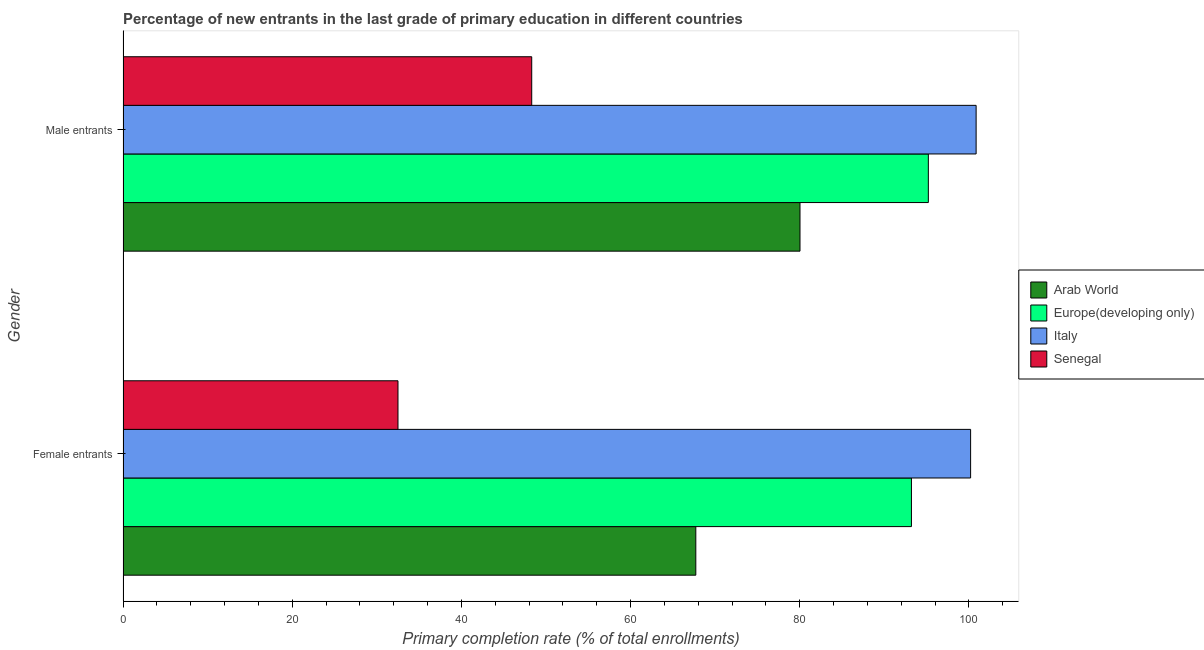How many groups of bars are there?
Offer a terse response. 2. Are the number of bars per tick equal to the number of legend labels?
Your answer should be compact. Yes. Are the number of bars on each tick of the Y-axis equal?
Your answer should be compact. Yes. What is the label of the 1st group of bars from the top?
Offer a very short reply. Male entrants. What is the primary completion rate of male entrants in Europe(developing only)?
Provide a short and direct response. 95.21. Across all countries, what is the maximum primary completion rate of female entrants?
Keep it short and to the point. 100.21. Across all countries, what is the minimum primary completion rate of female entrants?
Make the answer very short. 32.51. In which country was the primary completion rate of male entrants minimum?
Give a very brief answer. Senegal. What is the total primary completion rate of female entrants in the graph?
Offer a terse response. 293.65. What is the difference between the primary completion rate of female entrants in Senegal and that in Arab World?
Provide a short and direct response. -35.21. What is the difference between the primary completion rate of female entrants in Arab World and the primary completion rate of male entrants in Senegal?
Your answer should be compact. 19.4. What is the average primary completion rate of male entrants per country?
Provide a succinct answer. 81.11. What is the difference between the primary completion rate of female entrants and primary completion rate of male entrants in Senegal?
Offer a terse response. -15.81. What is the ratio of the primary completion rate of female entrants in Arab World to that in Italy?
Give a very brief answer. 0.68. What does the 1st bar from the top in Male entrants represents?
Offer a very short reply. Senegal. How many bars are there?
Make the answer very short. 8. How many countries are there in the graph?
Ensure brevity in your answer.  4. Where does the legend appear in the graph?
Offer a very short reply. Center right. What is the title of the graph?
Your answer should be very brief. Percentage of new entrants in the last grade of primary education in different countries. Does "Grenada" appear as one of the legend labels in the graph?
Your response must be concise. No. What is the label or title of the X-axis?
Make the answer very short. Primary completion rate (% of total enrollments). What is the Primary completion rate (% of total enrollments) of Arab World in Female entrants?
Your response must be concise. 67.72. What is the Primary completion rate (% of total enrollments) in Europe(developing only) in Female entrants?
Make the answer very short. 93.21. What is the Primary completion rate (% of total enrollments) of Italy in Female entrants?
Ensure brevity in your answer.  100.21. What is the Primary completion rate (% of total enrollments) in Senegal in Female entrants?
Your answer should be very brief. 32.51. What is the Primary completion rate (% of total enrollments) in Arab World in Male entrants?
Your answer should be very brief. 80.04. What is the Primary completion rate (% of total enrollments) in Europe(developing only) in Male entrants?
Ensure brevity in your answer.  95.21. What is the Primary completion rate (% of total enrollments) in Italy in Male entrants?
Offer a terse response. 100.86. What is the Primary completion rate (% of total enrollments) of Senegal in Male entrants?
Your response must be concise. 48.32. Across all Gender, what is the maximum Primary completion rate (% of total enrollments) in Arab World?
Make the answer very short. 80.04. Across all Gender, what is the maximum Primary completion rate (% of total enrollments) in Europe(developing only)?
Offer a very short reply. 95.21. Across all Gender, what is the maximum Primary completion rate (% of total enrollments) in Italy?
Offer a terse response. 100.86. Across all Gender, what is the maximum Primary completion rate (% of total enrollments) in Senegal?
Your answer should be compact. 48.32. Across all Gender, what is the minimum Primary completion rate (% of total enrollments) of Arab World?
Give a very brief answer. 67.72. Across all Gender, what is the minimum Primary completion rate (% of total enrollments) of Europe(developing only)?
Provide a short and direct response. 93.21. Across all Gender, what is the minimum Primary completion rate (% of total enrollments) of Italy?
Provide a succinct answer. 100.21. Across all Gender, what is the minimum Primary completion rate (% of total enrollments) of Senegal?
Give a very brief answer. 32.51. What is the total Primary completion rate (% of total enrollments) of Arab World in the graph?
Give a very brief answer. 147.75. What is the total Primary completion rate (% of total enrollments) in Europe(developing only) in the graph?
Your response must be concise. 188.42. What is the total Primary completion rate (% of total enrollments) of Italy in the graph?
Provide a succinct answer. 201.06. What is the total Primary completion rate (% of total enrollments) of Senegal in the graph?
Keep it short and to the point. 80.83. What is the difference between the Primary completion rate (% of total enrollments) of Arab World in Female entrants and that in Male entrants?
Your response must be concise. -12.32. What is the difference between the Primary completion rate (% of total enrollments) of Europe(developing only) in Female entrants and that in Male entrants?
Your response must be concise. -2. What is the difference between the Primary completion rate (% of total enrollments) in Italy in Female entrants and that in Male entrants?
Provide a succinct answer. -0.65. What is the difference between the Primary completion rate (% of total enrollments) of Senegal in Female entrants and that in Male entrants?
Offer a terse response. -15.81. What is the difference between the Primary completion rate (% of total enrollments) in Arab World in Female entrants and the Primary completion rate (% of total enrollments) in Europe(developing only) in Male entrants?
Keep it short and to the point. -27.49. What is the difference between the Primary completion rate (% of total enrollments) in Arab World in Female entrants and the Primary completion rate (% of total enrollments) in Italy in Male entrants?
Your answer should be compact. -33.14. What is the difference between the Primary completion rate (% of total enrollments) of Arab World in Female entrants and the Primary completion rate (% of total enrollments) of Senegal in Male entrants?
Make the answer very short. 19.4. What is the difference between the Primary completion rate (% of total enrollments) of Europe(developing only) in Female entrants and the Primary completion rate (% of total enrollments) of Italy in Male entrants?
Give a very brief answer. -7.65. What is the difference between the Primary completion rate (% of total enrollments) of Europe(developing only) in Female entrants and the Primary completion rate (% of total enrollments) of Senegal in Male entrants?
Provide a succinct answer. 44.89. What is the difference between the Primary completion rate (% of total enrollments) in Italy in Female entrants and the Primary completion rate (% of total enrollments) in Senegal in Male entrants?
Keep it short and to the point. 51.89. What is the average Primary completion rate (% of total enrollments) of Arab World per Gender?
Ensure brevity in your answer.  73.88. What is the average Primary completion rate (% of total enrollments) of Europe(developing only) per Gender?
Keep it short and to the point. 94.21. What is the average Primary completion rate (% of total enrollments) of Italy per Gender?
Provide a succinct answer. 100.53. What is the average Primary completion rate (% of total enrollments) in Senegal per Gender?
Your response must be concise. 40.41. What is the difference between the Primary completion rate (% of total enrollments) of Arab World and Primary completion rate (% of total enrollments) of Europe(developing only) in Female entrants?
Provide a short and direct response. -25.49. What is the difference between the Primary completion rate (% of total enrollments) in Arab World and Primary completion rate (% of total enrollments) in Italy in Female entrants?
Make the answer very short. -32.49. What is the difference between the Primary completion rate (% of total enrollments) in Arab World and Primary completion rate (% of total enrollments) in Senegal in Female entrants?
Provide a succinct answer. 35.21. What is the difference between the Primary completion rate (% of total enrollments) in Europe(developing only) and Primary completion rate (% of total enrollments) in Italy in Female entrants?
Provide a short and direct response. -7. What is the difference between the Primary completion rate (% of total enrollments) in Europe(developing only) and Primary completion rate (% of total enrollments) in Senegal in Female entrants?
Ensure brevity in your answer.  60.7. What is the difference between the Primary completion rate (% of total enrollments) in Italy and Primary completion rate (% of total enrollments) in Senegal in Female entrants?
Make the answer very short. 67.7. What is the difference between the Primary completion rate (% of total enrollments) of Arab World and Primary completion rate (% of total enrollments) of Europe(developing only) in Male entrants?
Offer a terse response. -15.17. What is the difference between the Primary completion rate (% of total enrollments) in Arab World and Primary completion rate (% of total enrollments) in Italy in Male entrants?
Your answer should be compact. -20.82. What is the difference between the Primary completion rate (% of total enrollments) in Arab World and Primary completion rate (% of total enrollments) in Senegal in Male entrants?
Give a very brief answer. 31.72. What is the difference between the Primary completion rate (% of total enrollments) in Europe(developing only) and Primary completion rate (% of total enrollments) in Italy in Male entrants?
Offer a very short reply. -5.65. What is the difference between the Primary completion rate (% of total enrollments) of Europe(developing only) and Primary completion rate (% of total enrollments) of Senegal in Male entrants?
Offer a terse response. 46.89. What is the difference between the Primary completion rate (% of total enrollments) in Italy and Primary completion rate (% of total enrollments) in Senegal in Male entrants?
Ensure brevity in your answer.  52.54. What is the ratio of the Primary completion rate (% of total enrollments) in Arab World in Female entrants to that in Male entrants?
Your answer should be compact. 0.85. What is the ratio of the Primary completion rate (% of total enrollments) in Italy in Female entrants to that in Male entrants?
Offer a very short reply. 0.99. What is the ratio of the Primary completion rate (% of total enrollments) in Senegal in Female entrants to that in Male entrants?
Make the answer very short. 0.67. What is the difference between the highest and the second highest Primary completion rate (% of total enrollments) in Arab World?
Your response must be concise. 12.32. What is the difference between the highest and the second highest Primary completion rate (% of total enrollments) in Europe(developing only)?
Provide a succinct answer. 2. What is the difference between the highest and the second highest Primary completion rate (% of total enrollments) in Italy?
Give a very brief answer. 0.65. What is the difference between the highest and the second highest Primary completion rate (% of total enrollments) of Senegal?
Provide a succinct answer. 15.81. What is the difference between the highest and the lowest Primary completion rate (% of total enrollments) in Arab World?
Offer a very short reply. 12.32. What is the difference between the highest and the lowest Primary completion rate (% of total enrollments) of Europe(developing only)?
Ensure brevity in your answer.  2. What is the difference between the highest and the lowest Primary completion rate (% of total enrollments) of Italy?
Offer a very short reply. 0.65. What is the difference between the highest and the lowest Primary completion rate (% of total enrollments) in Senegal?
Make the answer very short. 15.81. 